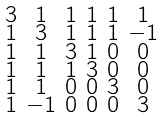<formula> <loc_0><loc_0><loc_500><loc_500>\begin{smallmatrix} 3 & 1 & 1 & 1 & 1 & 1 \\ 1 & 3 & 1 & 1 & 1 & - 1 \\ 1 & 1 & 3 & 1 & 0 & 0 \\ 1 & 1 & 1 & 3 & 0 & 0 \\ 1 & 1 & 0 & 0 & 3 & 0 \\ 1 & - 1 & 0 & 0 & 0 & 3 \end{smallmatrix}</formula> 